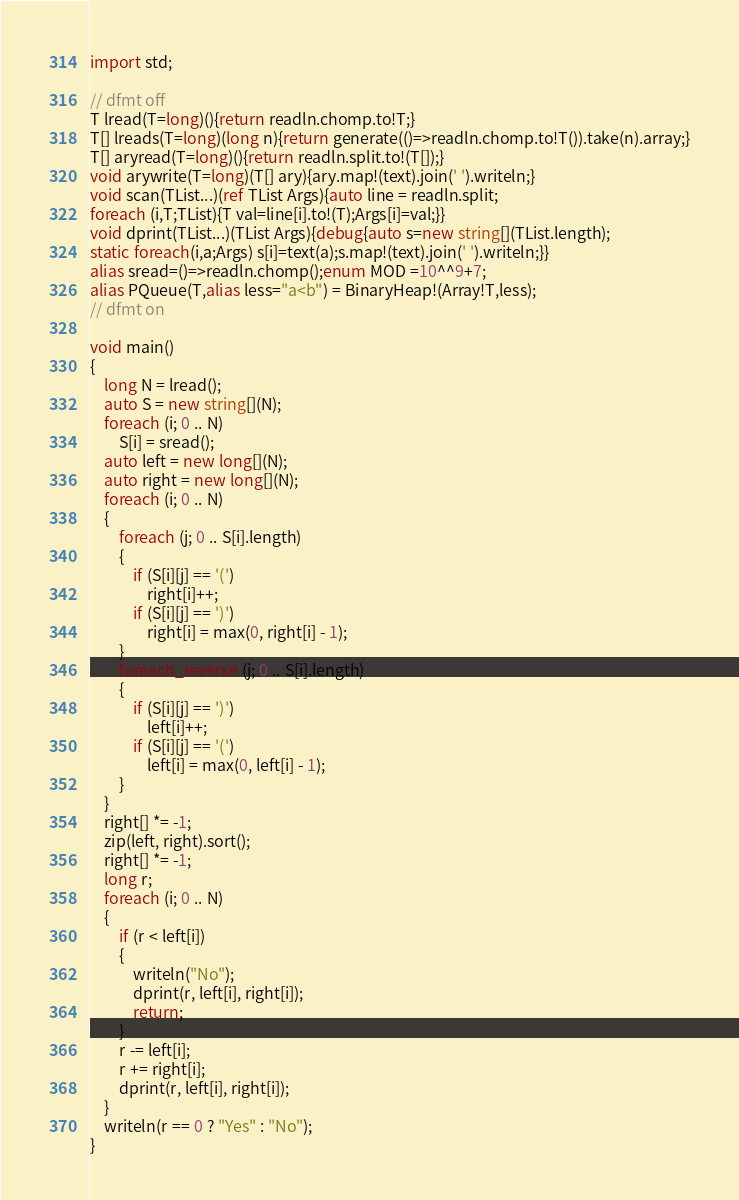<code> <loc_0><loc_0><loc_500><loc_500><_D_>import std;

// dfmt off
T lread(T=long)(){return readln.chomp.to!T;}
T[] lreads(T=long)(long n){return generate(()=>readln.chomp.to!T()).take(n).array;}
T[] aryread(T=long)(){return readln.split.to!(T[]);}
void arywrite(T=long)(T[] ary){ary.map!(text).join(' ').writeln;}
void scan(TList...)(ref TList Args){auto line = readln.split;
foreach (i,T;TList){T val=line[i].to!(T);Args[i]=val;}}
void dprint(TList...)(TList Args){debug{auto s=new string[](TList.length);
static foreach(i,a;Args) s[i]=text(a);s.map!(text).join(' ').writeln;}}
alias sread=()=>readln.chomp();enum MOD =10^^9+7;
alias PQueue(T,alias less="a<b") = BinaryHeap!(Array!T,less);
// dfmt on

void main()
{
    long N = lread();
    auto S = new string[](N);
    foreach (i; 0 .. N)
        S[i] = sread();
    auto left = new long[](N);
    auto right = new long[](N);
    foreach (i; 0 .. N)
    {
        foreach (j; 0 .. S[i].length)
        {
            if (S[i][j] == '(')
                right[i]++;
            if (S[i][j] == ')')
                right[i] = max(0, right[i] - 1);
        }
        foreach_reverse (j; 0 .. S[i].length)
        {
            if (S[i][j] == ')')
                left[i]++;
            if (S[i][j] == '(')
                left[i] = max(0, left[i] - 1);
        }
    }
    right[] *= -1;
    zip(left, right).sort();
    right[] *= -1;
    long r;
    foreach (i; 0 .. N)
    {
        if (r < left[i])
        {
            writeln("No");
            dprint(r, left[i], right[i]);
            return;
        }
        r -= left[i];
        r += right[i];
        dprint(r, left[i], right[i]);
    }
    writeln(r == 0 ? "Yes" : "No");
}
</code> 